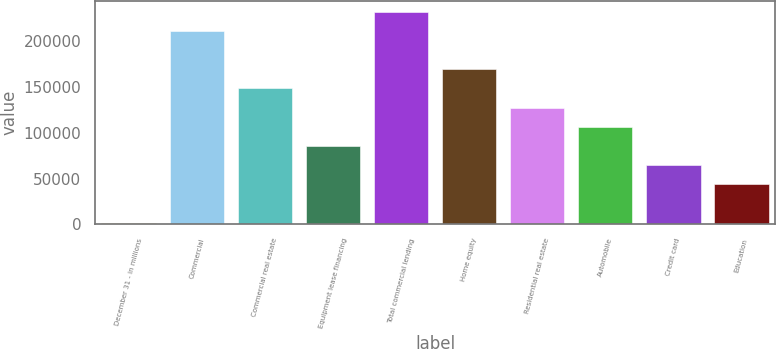Convert chart to OTSL. <chart><loc_0><loc_0><loc_500><loc_500><bar_chart><fcel>December 31 - in millions<fcel>Commercial<fcel>Commercial real estate<fcel>Equipment lease financing<fcel>Total commercial lending<fcel>Home equity<fcel>Residential real estate<fcel>Automobile<fcel>Credit card<fcel>Education<nl><fcel>2016<fcel>210833<fcel>148188<fcel>85542.8<fcel>231715<fcel>169070<fcel>127306<fcel>106424<fcel>64661.1<fcel>43779.4<nl></chart> 